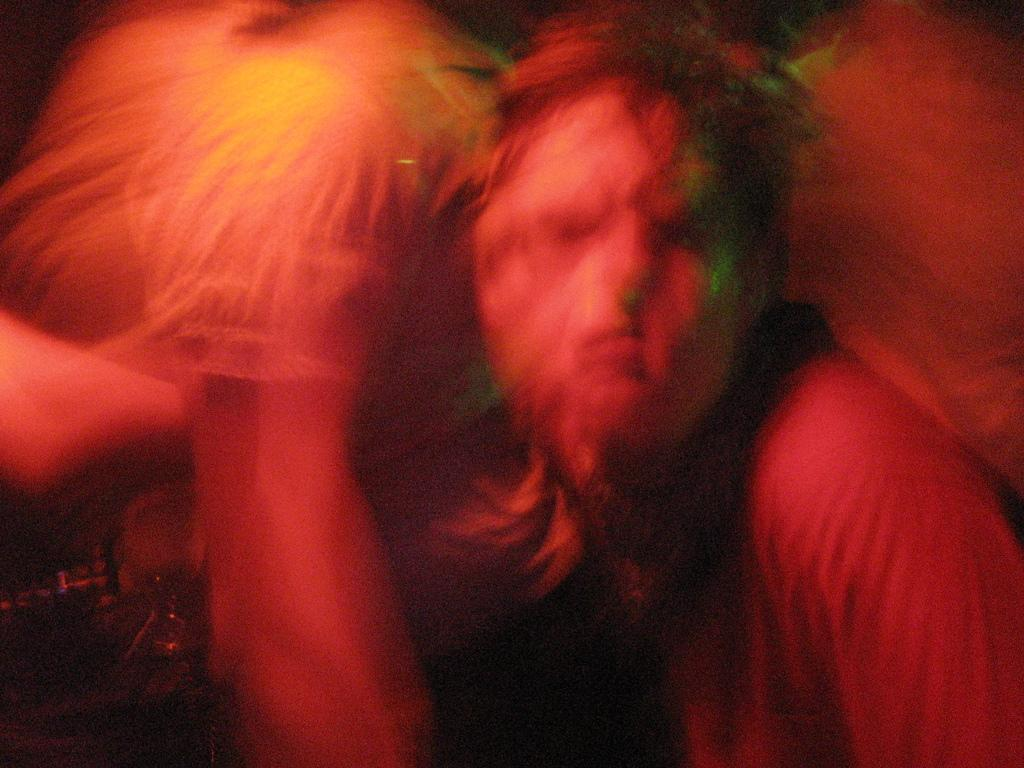What is happening between the two people in the image? There is a person holding another person in the image. Can you describe the relationship between the two people? The relationship between the two people cannot be determined from the image alone. What might be the reason for one person holding the other person? The reason for one person holding the other person cannot be determined from the image alone. What type of cactus can be seen growing in the person's stomach in the image? There is no cactus visible in the image, nor is there any indication of a cactus growing in a person's stomach. 